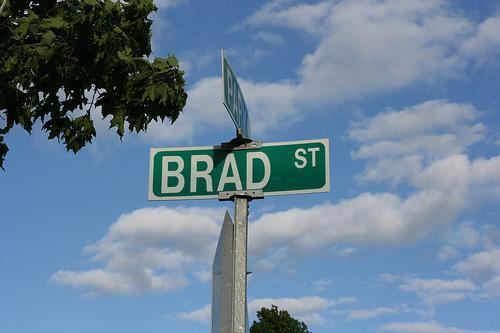How many signs are in the picture?
Give a very brief answer. 2. 